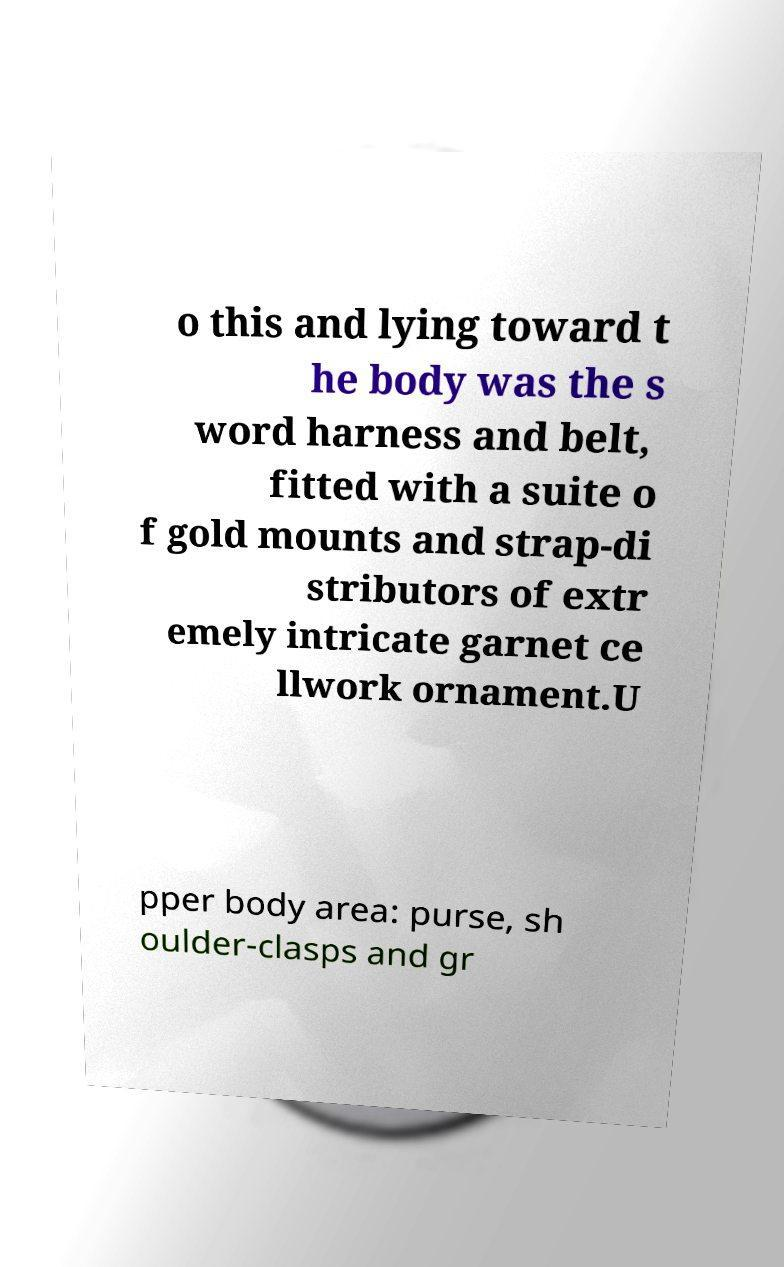I need the written content from this picture converted into text. Can you do that? o this and lying toward t he body was the s word harness and belt, fitted with a suite o f gold mounts and strap-di stributors of extr emely intricate garnet ce llwork ornament.U pper body area: purse, sh oulder-clasps and gr 